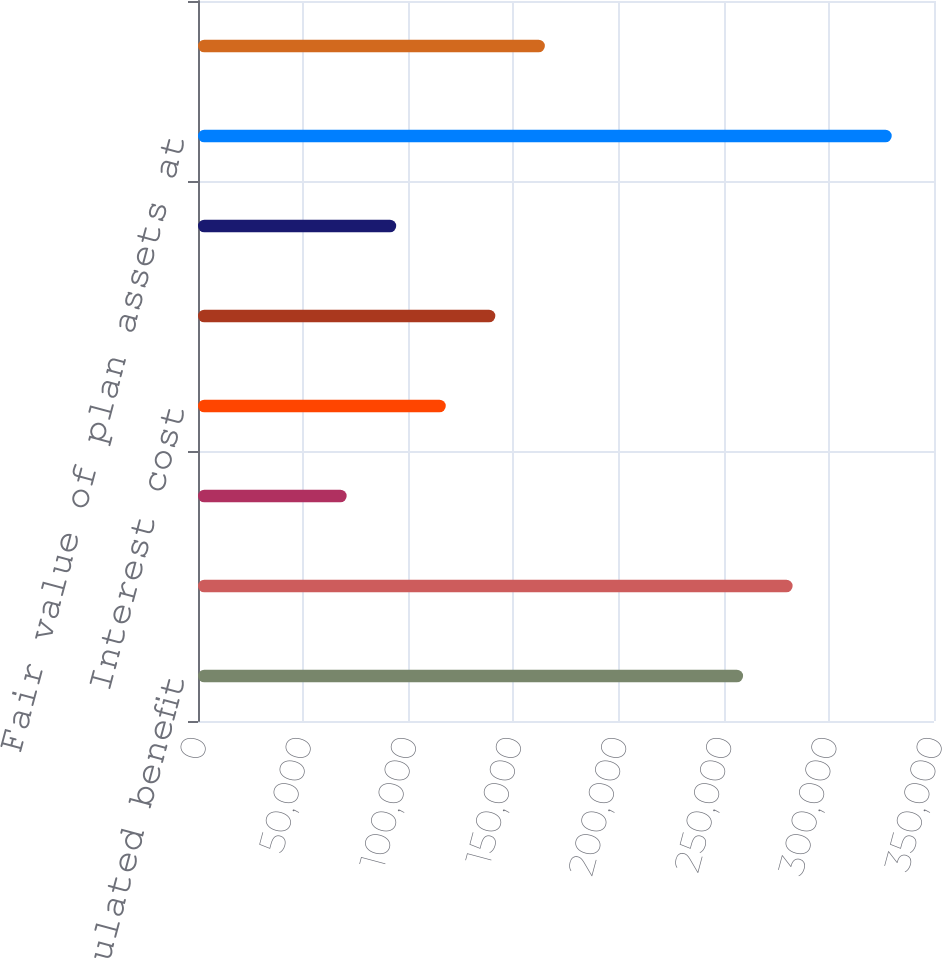<chart> <loc_0><loc_0><loc_500><loc_500><bar_chart><fcel>Accumulated benefit<fcel>Projected benefit obligations<fcel>Service cost<fcel>Interest cost<fcel>Benefits paid and plan<fcel>Actuarial (gain) loss<fcel>Fair value of plan assets at<fcel>Actual (loss) return on plan<nl><fcel>259205<fcel>282768<fcel>70694.8<fcel>117822<fcel>141386<fcel>94258.5<fcel>329896<fcel>164950<nl></chart> 